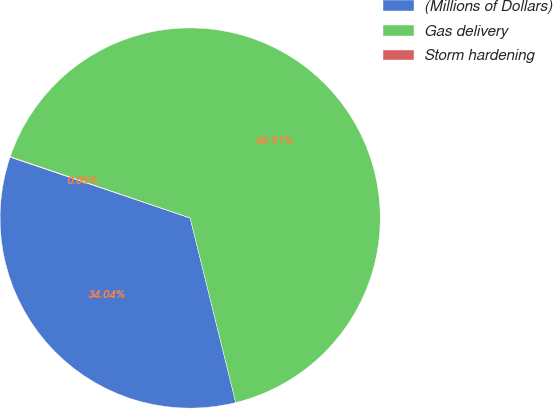<chart> <loc_0><loc_0><loc_500><loc_500><pie_chart><fcel>(Millions of Dollars)<fcel>Gas delivery<fcel>Storm hardening<nl><fcel>34.04%<fcel>65.91%<fcel>0.05%<nl></chart> 